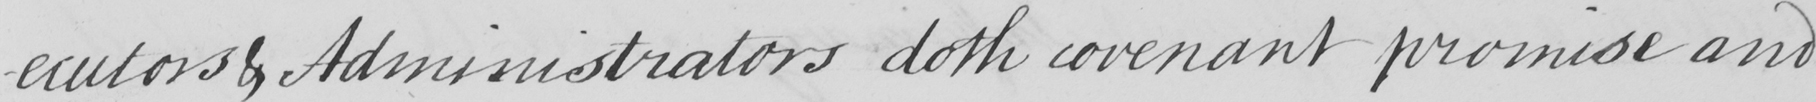Can you tell me what this handwritten text says? -ecutors & Administrators doth covenant promise and 